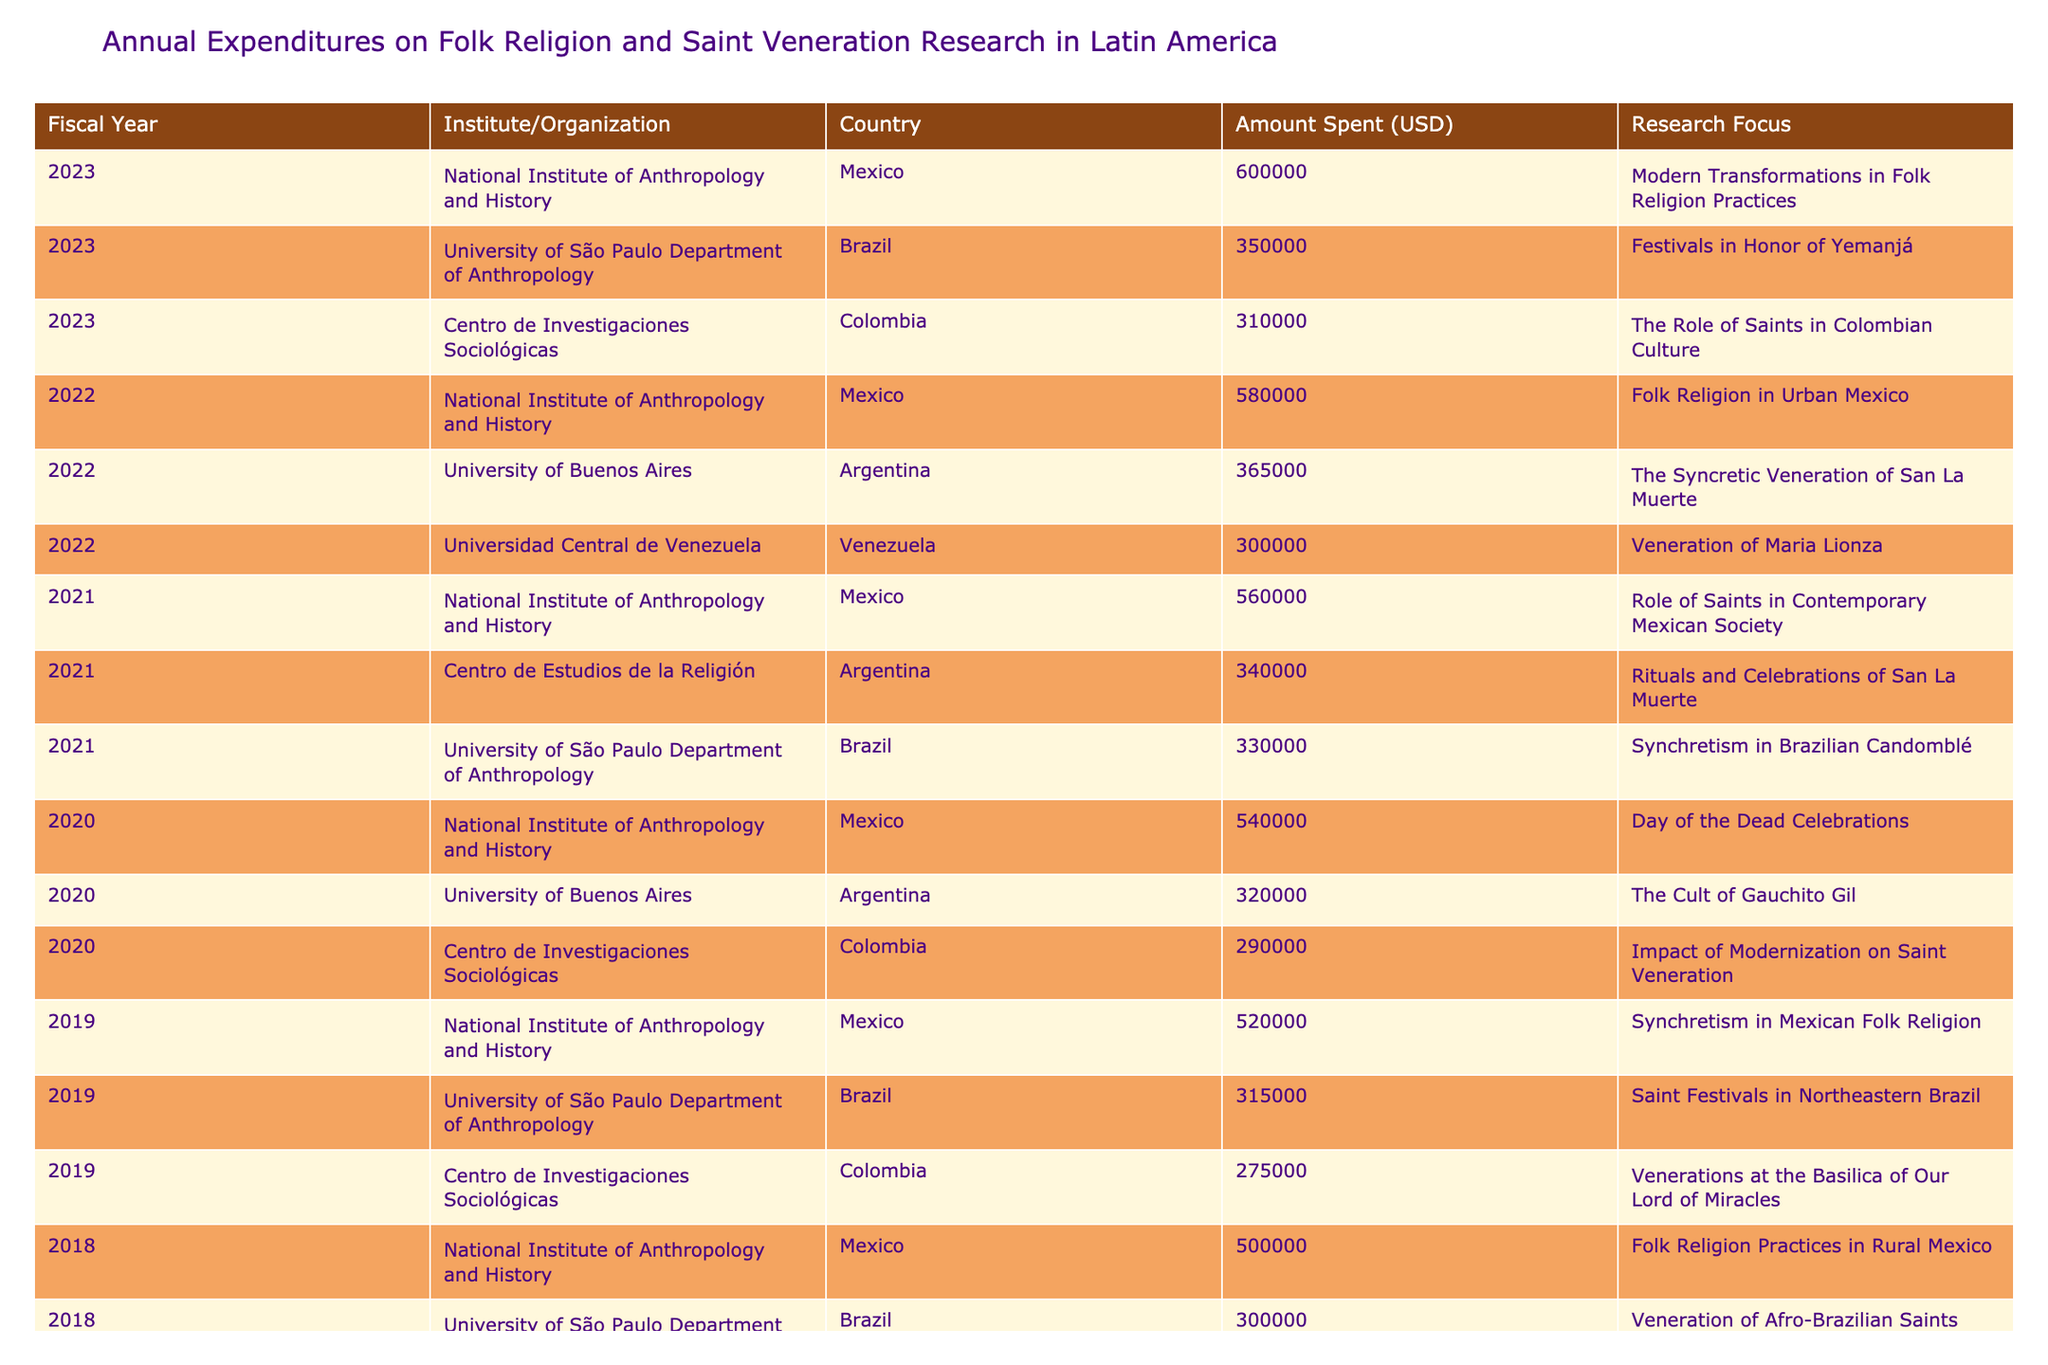What was the total amount spent on research focusing on Folk Religion Practices in Rural Mexico across the years? The total amount spent specifically on "Folk Religion Practices in Rural Mexico" is $500,000 in 2018, $520,000 in 2019, $540,000 in 2020, $560,000 in 2021, $580,000 in 2022, and $600,000 in 2023. Adding these amounts together results in $500,000 + $520,000 + $540,000 + $560,000 + $580,000 + $600,000 = $3,300,000.
Answer: 3,300,000 Which organization had the highest expenditure in 2023? In 2023, the National Institute of Anthropology and History spent $600,000, which is higher than the other organizations' expenditures: University of São Paulo Department of Anthropology ($350,000) and Centro de Investigaciones Sociológicas ($310,000). Therefore, it had the highest expenditure in 2023.
Answer: National Institute of Anthropology and History Did Centro de Investigaciones Sociológicas ever focus on the veneration of saints in their research? Yes, Centro de Investigaciones Sociológicas focused on the veneration of saints, specifically on "Venerations at the Basilica of Our Lord of Miracles" in Colombia in 2019 and "The Role of Saints in Colombian Culture" in 2023. Thus, the answer is yes.
Answer: Yes What is the average amount spent on research focusing on Argentina from 2018 to 2023? The amounts spent on Argentina from 2018 to 2023 are: $250,000 (2018), $320,000 (2020), $340,000 (2021), $365,000 (2022). The total amount is $250,000 + $320,000 + $340,000 + $365,000 = $1,275,000. There are 4 data points, so the average is $1,275,000 / 4 = $318,750.
Answer: 318,750 Was there a year without any research expenditures on the Veneration of Maria Lionza? Yes, all mentioned years in the table show specific amounts attributed to different research areas, and the only mention of “Veneration of Maria Lionza” was in 2022 for $300,000. Therefore, the answer is that there were years without expenditures for that area.
Answer: Yes 